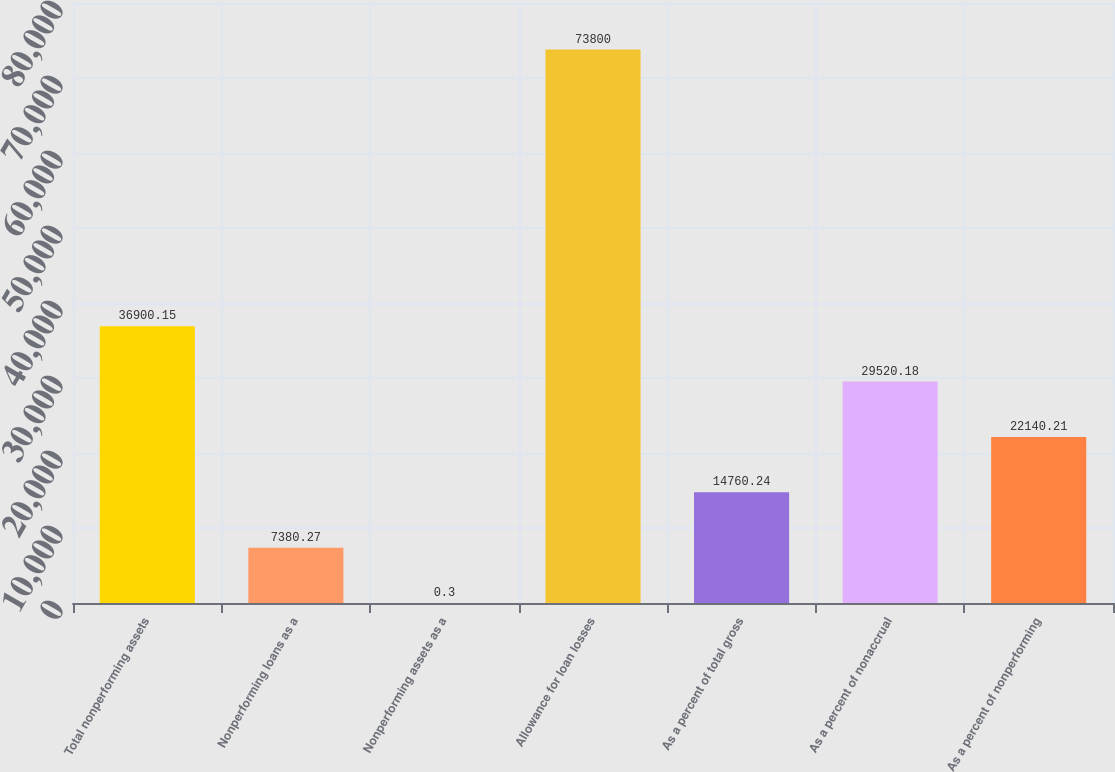<chart> <loc_0><loc_0><loc_500><loc_500><bar_chart><fcel>Total nonperforming assets<fcel>Nonperforming loans as a<fcel>Nonperforming assets as a<fcel>Allowance for loan losses<fcel>As a percent of total gross<fcel>As a percent of nonaccrual<fcel>As a percent of nonperforming<nl><fcel>36900.2<fcel>7380.27<fcel>0.3<fcel>73800<fcel>14760.2<fcel>29520.2<fcel>22140.2<nl></chart> 